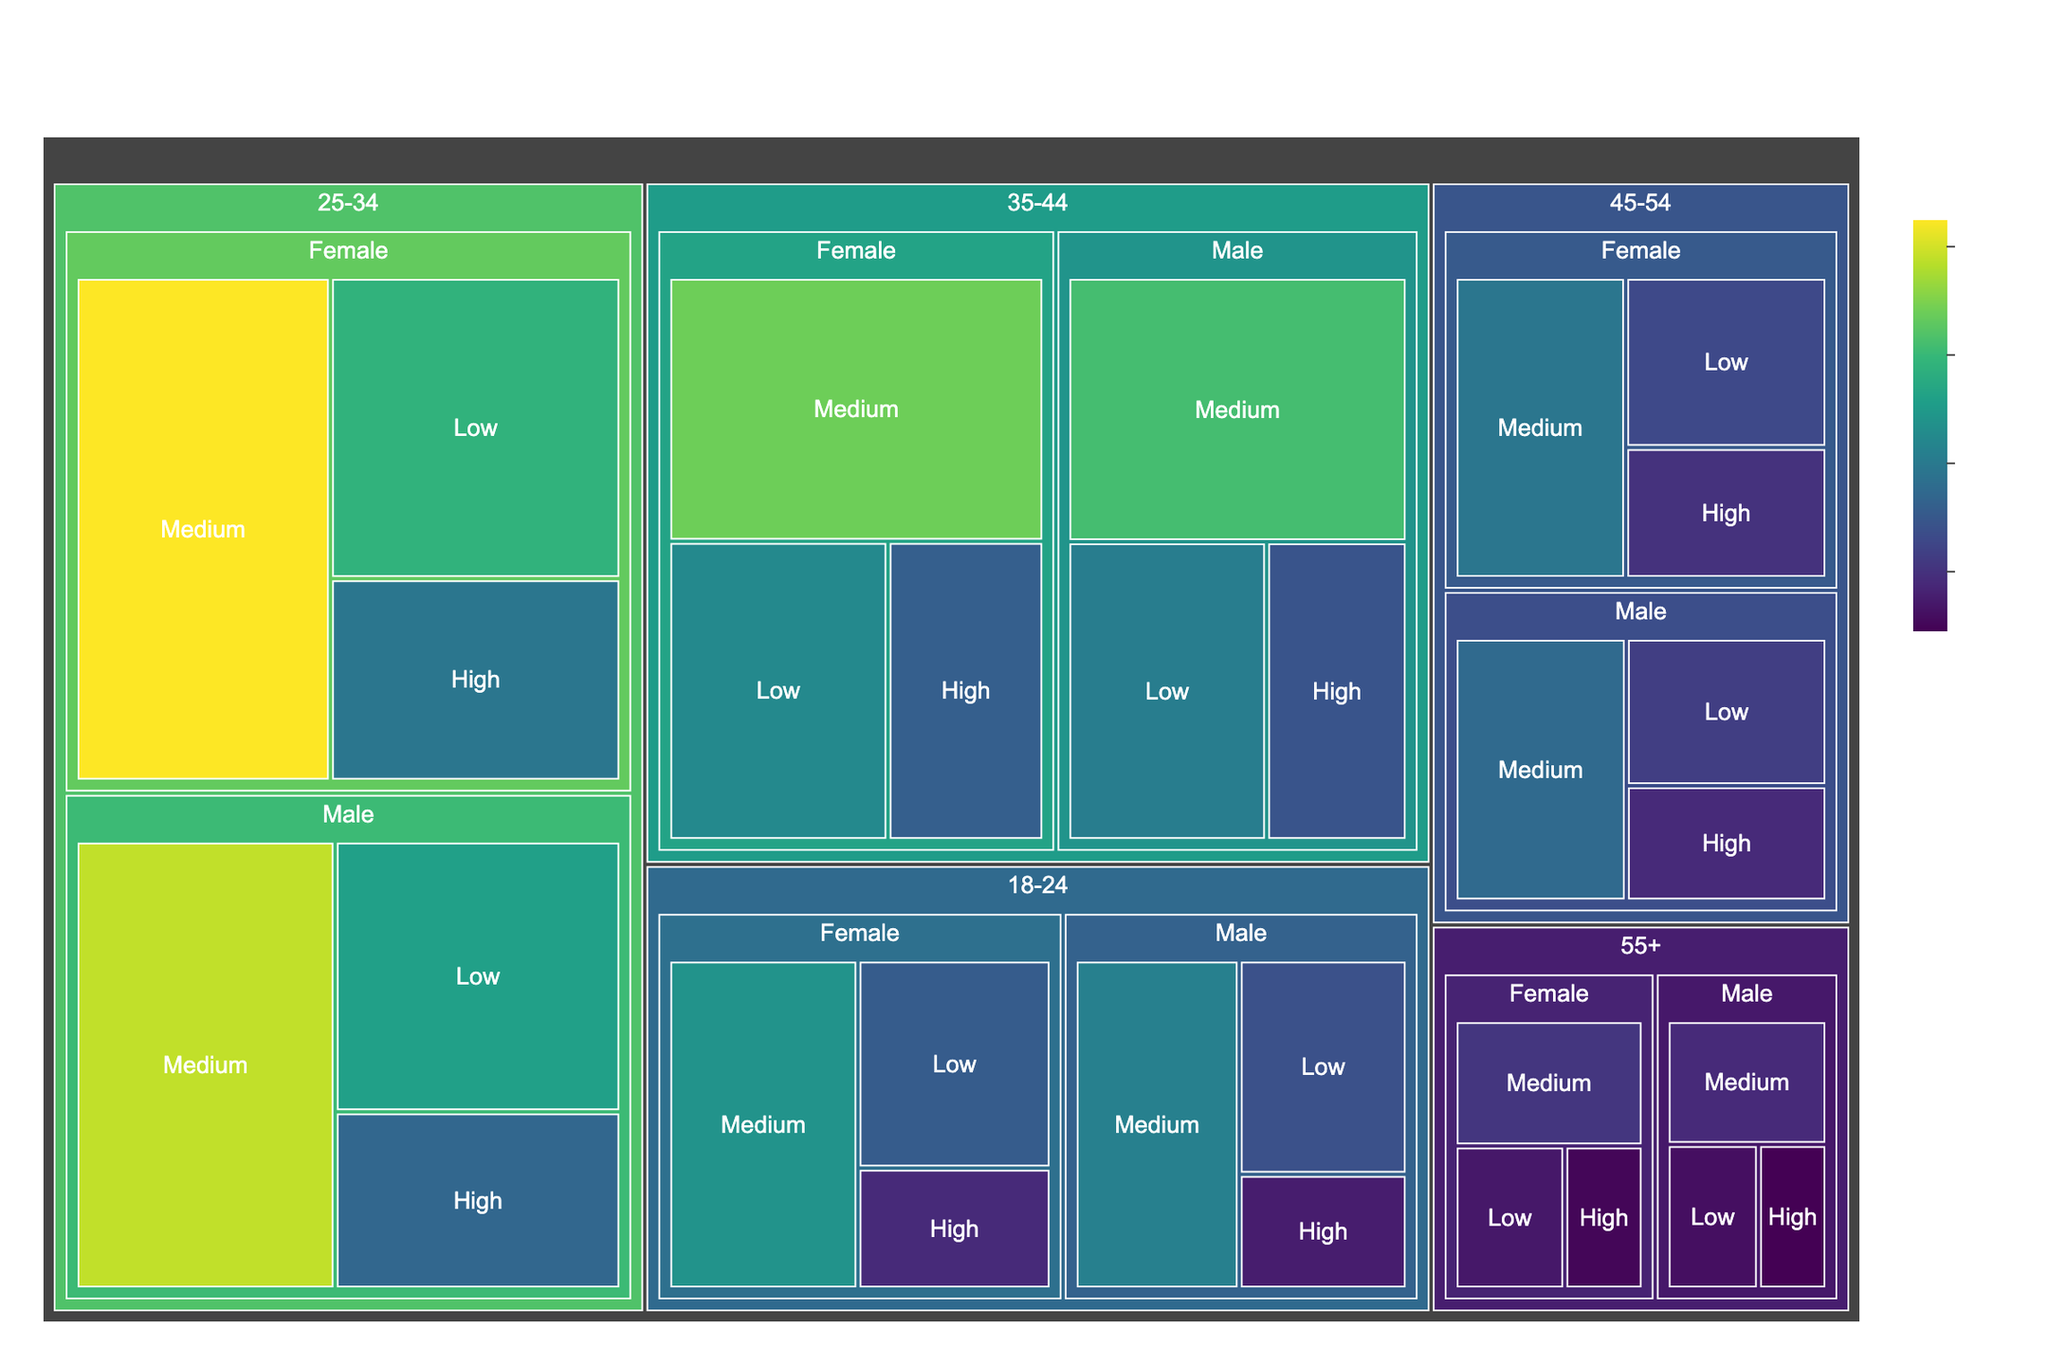What is the title of the treemap figure? The title is usually prominently displayed at the top of the figure, indicating the subject of the plot.
Answer: Demographic Breakdown of Streaming Service Users in the Middle East How many user segments are represented in the 18-24 age group? There are six segments in the 18-24 age group, divided by gender (Male, Female) and income levels (Low, Medium, High). Each age group has the same segmentation.
Answer: 6 Which gender has the higher number of users in the 25-34 age group? By comparing the sizes of the respective treemap sections, we see that females have a larger sum of users across all income levels than males in the 25-34 age group.
Answer: Female In the 35-44 age group, which income level has the lowest number of male users? The smallest segment in the 35-44 male category is the high-income level. This can be inferred by looking at the relative sizes of the treemap sections.
Answer: High What is the total number of users in the 55+ Female Low and Medium income levels combined? Low has 140,000 users and Medium has 210,000 users. Adding these together, 140,000 + 210,000 = 350,000.
Answer: 350,000 How does the number of medium-income users in the 45-54 male group compare to the high-income users in the same group? Medium-income users in 45-54 male group are 350,000, while high-income users in the same group are 180,000. Medium is greater than high.
Answer: Medium is higher Which age group has the highest number of users in the high-income level? By comparing the high-income segments across all age groups, the 25-34 age group has the largest segment for high-income users.
Answer: 25-34 What is the difference in the number of users between 18-24 Female Medium and 45-54 Female Medium income levels? 18-24 Female Medium has 480,000 users while 45-54 Female Medium has 390,000 users. The difference is 480,000 - 390,000 = 90,000.
Answer: 90,000 Which age and gender group has the lowest number of low-income users? By looking at the smallest segment among all low-income users, the 55+ Male Low income group has the fewest users, with 120,000.
Answer: 55+ Male How many more users does the 35-44 Female Medium income group have compared to the 18-24 Male Medium income group? 35-44 Female Medium has 680,000 users, and 18-24 Male Medium has 420,000 users. The difference is 680,000 - 420,000 = 260,000.
Answer: 260,000 